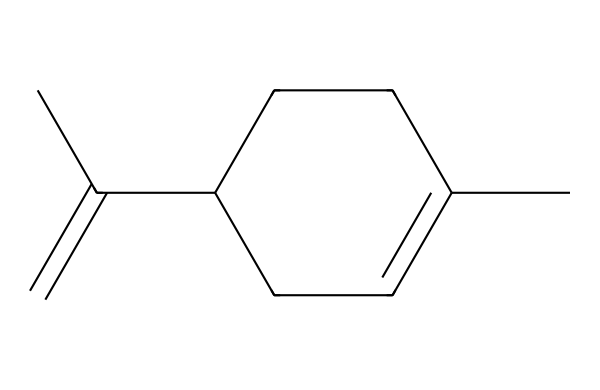What is the molecular formula of limonene? To find the molecular formula, we count the number of carbon (C), hydrogen (H), and possibly other atoms in the SMILES representation. The structure shows 10 carbon atoms and 16 hydrogen atoms, giving the formula C10H16.
Answer: C10H16 How many double bonds are present in limonene? By analyzing the structure, we observe that there is one double bond between two carbon atoms in the cyclohexene ring portion of the molecule and one in the methylene group. So, there are two double bonds.
Answer: two What type of isomerism can limonene exhibit? Limonene is a terpene and can exist as geometric isomers due to its double bonds, particularly because of the configuration around the double bond in the methylene group. It shows cis-trans isomerism.
Answer: cis-trans What influences the scent of limonene? The structure of limonene, specifically its arrangement of carbon and hydrogen atoms and the presence of the double bonds, determines its aromatic properties. The particular structure allows for its characteristic citrus scent.
Answer: structure What is the significance of the cyclic structure in limonene? The cyclic structure contributes to the stability of the molecule and affects its reactivity. It also plays a role in its biological functions and interactions with other molecules.
Answer: stability How does limonene relate to other terpenes? Limonene is one of the many terpenes characterized by its formula and structure, which includes a unique arrangement and the presence of a cyclohexene ring, distinguishing it from other terpenes.
Answer: unique arrangement What property of limonene makes it useful in cleaning products? The presence of hydrocarbons and its ability to dissolve oils make limonene effective in removing grease and stains, a property exploited in various cleaning products.
Answer: dissolve oils 